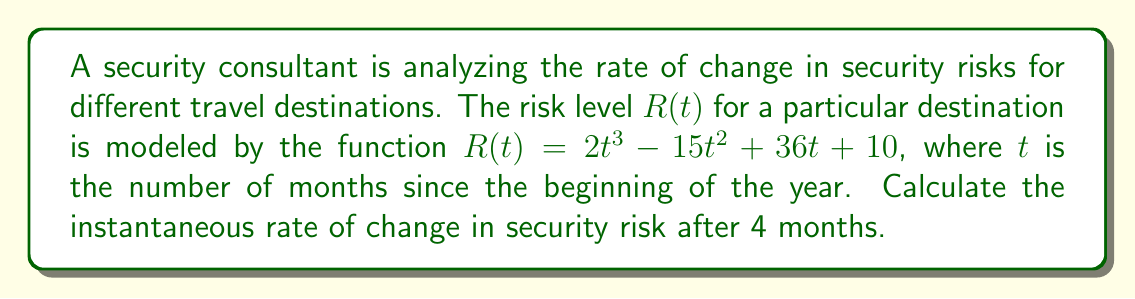Show me your answer to this math problem. To find the instantaneous rate of change in security risk after 4 months, we need to calculate the derivative of the function $R(t)$ and evaluate it at $t = 4$. This process involves the following steps:

1. Given function: $R(t) = 2t^3 - 15t^2 + 36t + 10$

2. Calculate the derivative $R'(t)$ using the power rule and constant rule:
   $$R'(t) = \frac{d}{dt}(2t^3 - 15t^2 + 36t + 10)$$
   $$R'(t) = 6t^2 - 30t + 36$$

3. Evaluate $R'(t)$ at $t = 4$:
   $$R'(4) = 6(4)^2 - 30(4) + 36$$
   $$R'(4) = 6(16) - 120 + 36$$
   $$R'(4) = 96 - 120 + 36$$
   $$R'(4) = 12$$

The instantaneous rate of change is the value of the derivative at the given point. In this case, it's 12 risk units per month after 4 months.
Answer: The instantaneous rate of change in security risk after 4 months is 12 risk units per month. 